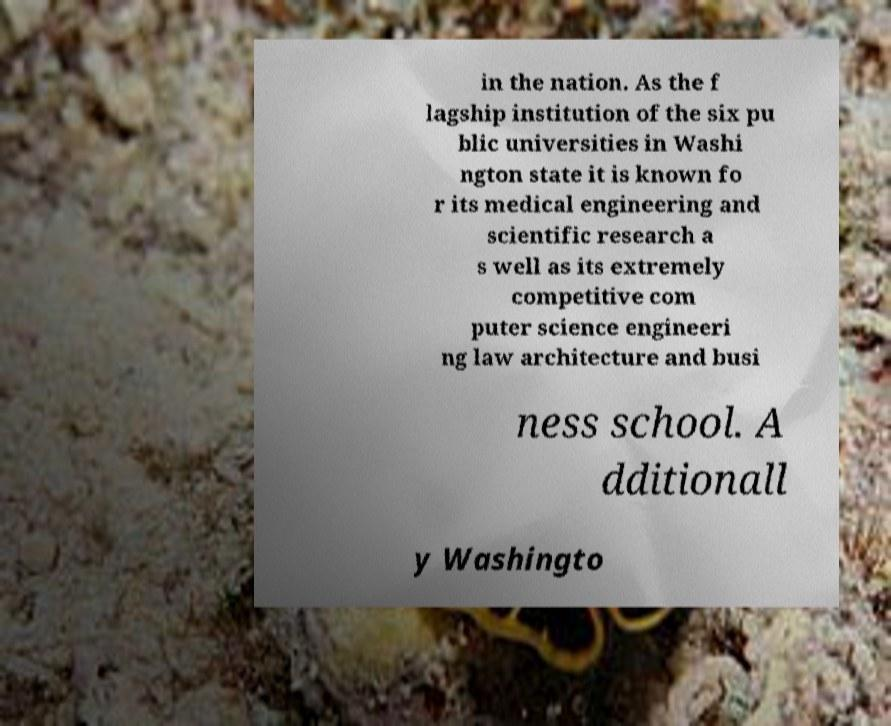Please read and relay the text visible in this image. What does it say? in the nation. As the f lagship institution of the six pu blic universities in Washi ngton state it is known fo r its medical engineering and scientific research a s well as its extremely competitive com puter science engineeri ng law architecture and busi ness school. A dditionall y Washingto 